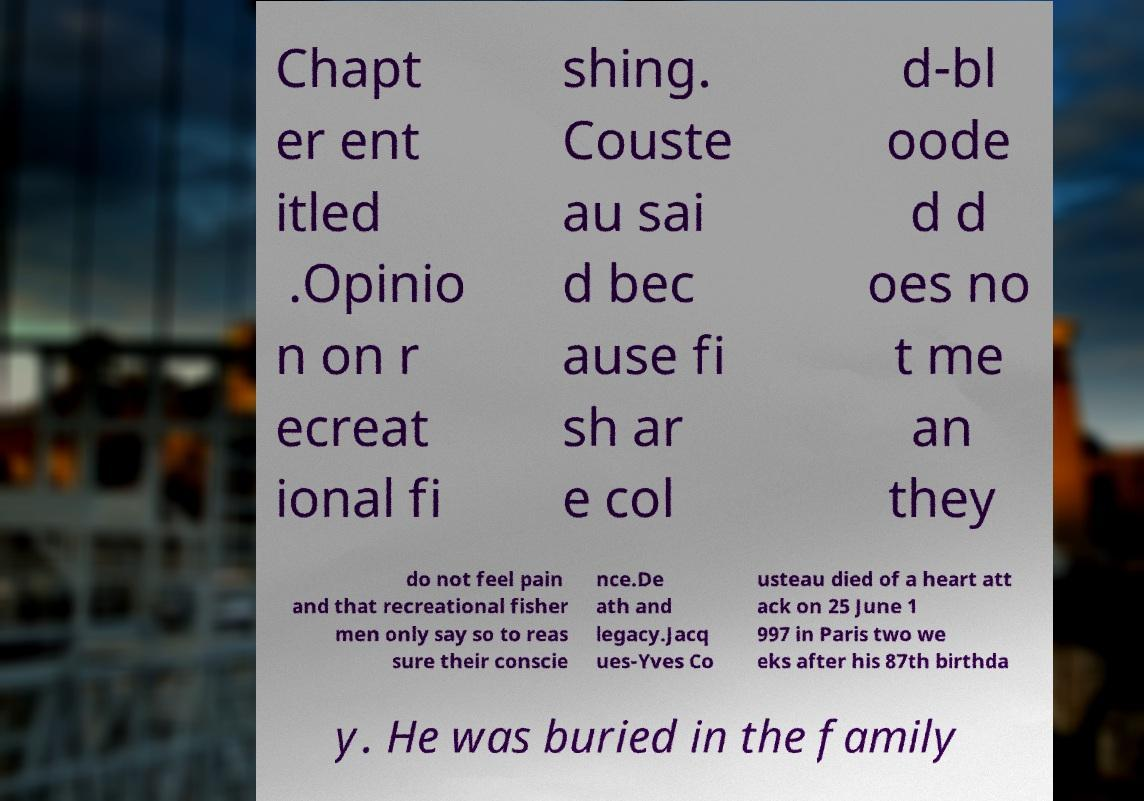Please read and relay the text visible in this image. What does it say? Chapt er ent itled .Opinio n on r ecreat ional fi shing. Couste au sai d bec ause fi sh ar e col d-bl oode d d oes no t me an they do not feel pain and that recreational fisher men only say so to reas sure their conscie nce.De ath and legacy.Jacq ues-Yves Co usteau died of a heart att ack on 25 June 1 997 in Paris two we eks after his 87th birthda y. He was buried in the family 